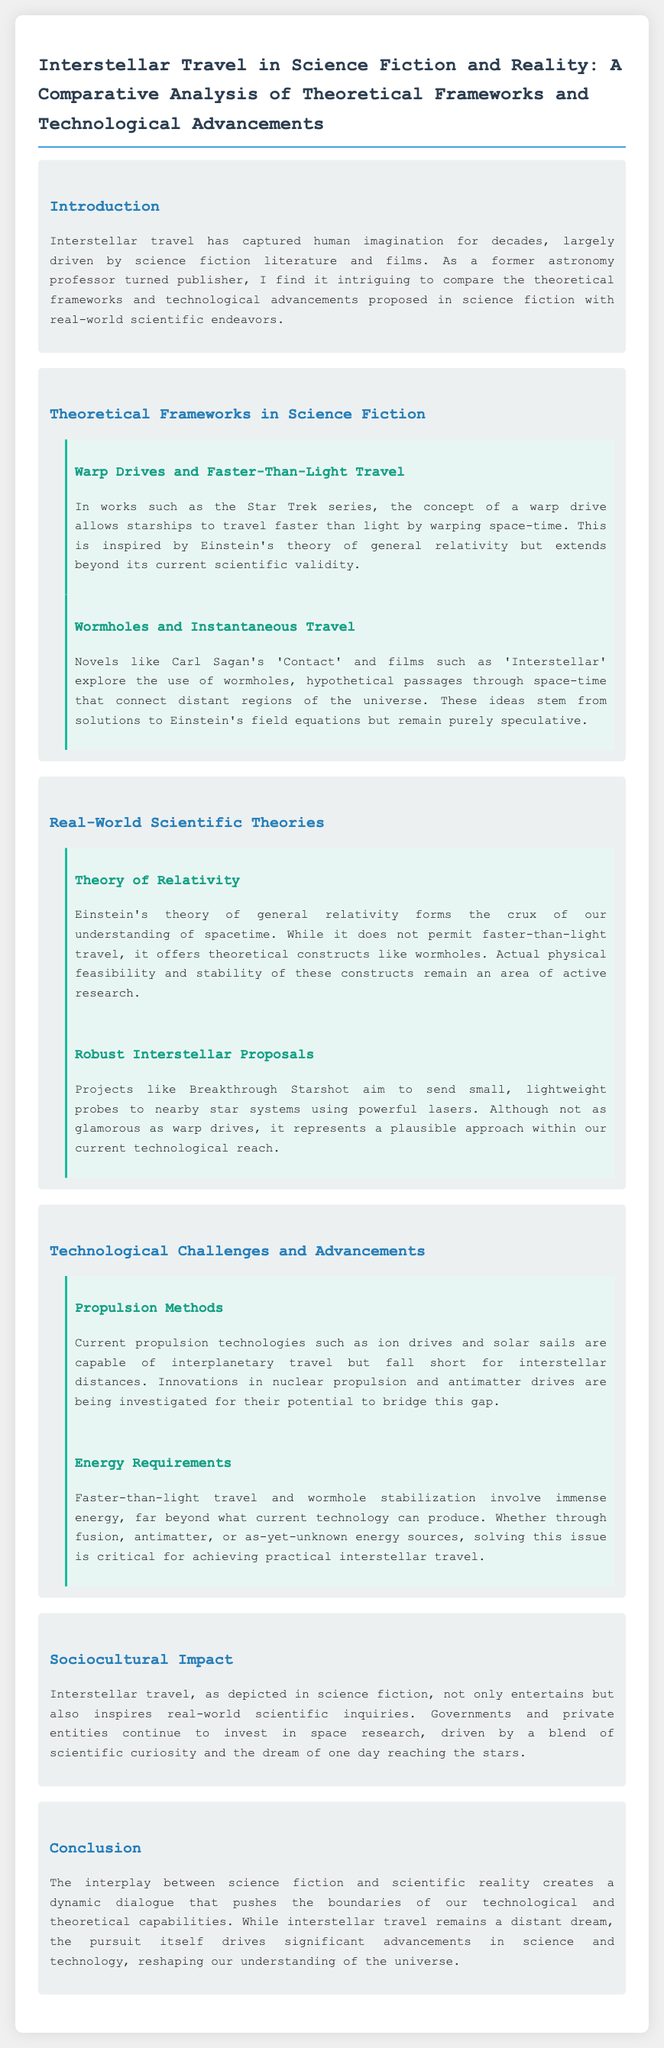What is the title of the document? The title is presented in the first section of the document.
Answer: Interstellar Travel in Science Fiction and Reality: A Comparative Analysis of Theoretical Frameworks and Technological Advancements Which science fiction series features warp drives? The document mentions a specific science fiction series known for its warp drive concept.
Answer: Star Trek What are two key constructs of Einstein's theory mentioned in the document? The document highlights important constructs related to spacetime from Einstein's theory.
Answer: Warp drives and wormholes Name one real-world scientific project aiming for interstellar travel. The document includes a mention of a specific project pursuing interstellar exploration.
Answer: Breakthrough Starshot What kind of propulsion methods are currently used for interplanetary travel? The section discussing propulsion methods specifies the technologies utilized currently.
Answer: Ion drives and solar sails What do current technological challenges for interstellar travel primarily involve? The document discusses challenges relating to a few specific areas for achieving interstellar travel.
Answer: Propulsion methods and energy requirements How does science fiction influence contemporary scientific inquiries? The document mentions the impact of science fiction on real-world research efforts.
Answer: Inspires real-world scientific inquiries What is a critical energy source requirement for faster-than-light travel? The document identifies a major energy challenge in achieving certain types of travel.
Answer: Immense energy 